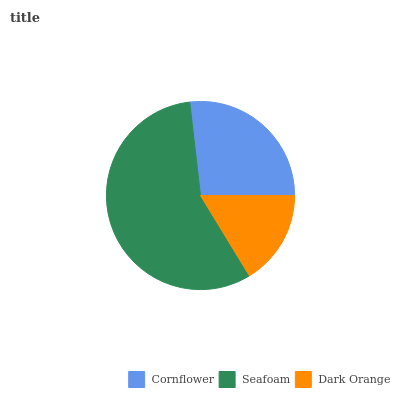Is Dark Orange the minimum?
Answer yes or no. Yes. Is Seafoam the maximum?
Answer yes or no. Yes. Is Seafoam the minimum?
Answer yes or no. No. Is Dark Orange the maximum?
Answer yes or no. No. Is Seafoam greater than Dark Orange?
Answer yes or no. Yes. Is Dark Orange less than Seafoam?
Answer yes or no. Yes. Is Dark Orange greater than Seafoam?
Answer yes or no. No. Is Seafoam less than Dark Orange?
Answer yes or no. No. Is Cornflower the high median?
Answer yes or no. Yes. Is Cornflower the low median?
Answer yes or no. Yes. Is Seafoam the high median?
Answer yes or no. No. Is Dark Orange the low median?
Answer yes or no. No. 